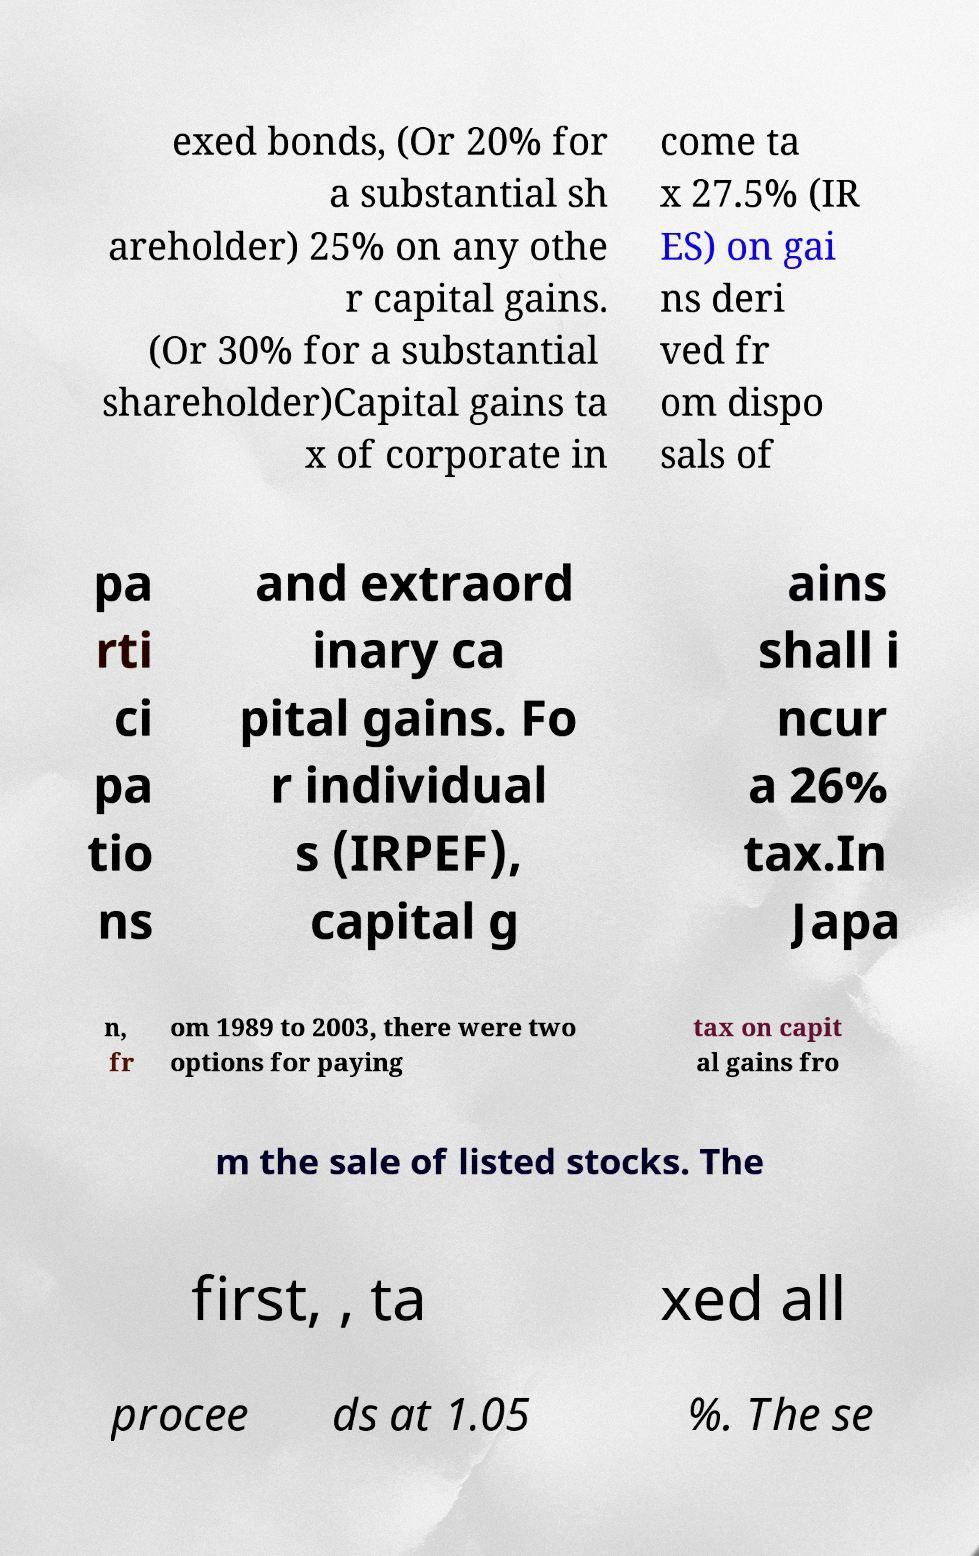I need the written content from this picture converted into text. Can you do that? exed bonds, (Or 20% for a substantial sh areholder) 25% on any othe r capital gains. (Or 30% for a substantial shareholder)Capital gains ta x of corporate in come ta x 27.5% (IR ES) on gai ns deri ved fr om dispo sals of pa rti ci pa tio ns and extraord inary ca pital gains. Fo r individual s (IRPEF), capital g ains shall i ncur a 26% tax.In Japa n, fr om 1989 to 2003, there were two options for paying tax on capit al gains fro m the sale of listed stocks. The first, , ta xed all procee ds at 1.05 %. The se 